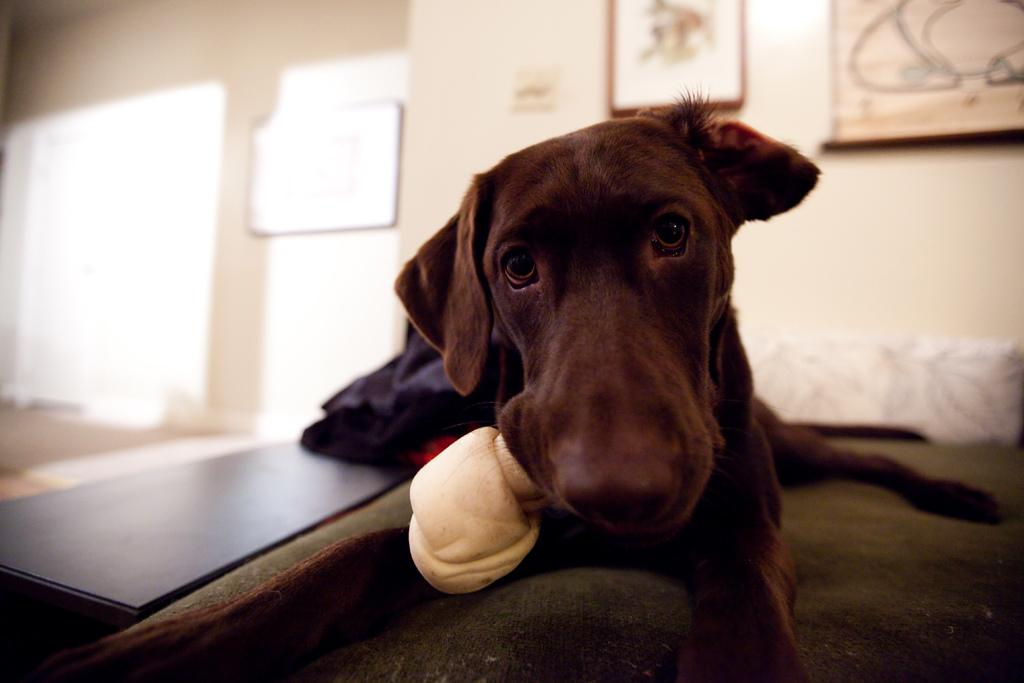What is the main subject in the foreground of the image? There is a dog in the foreground of the image. What is the dog doing in the image? The dog is sitting on the floor. Can you describe the background of the image? The background of the image is blurry. How many sisters does the dog have in the image? There are no sisters mentioned or depicted in the image, as it features a dog sitting on the floor. 